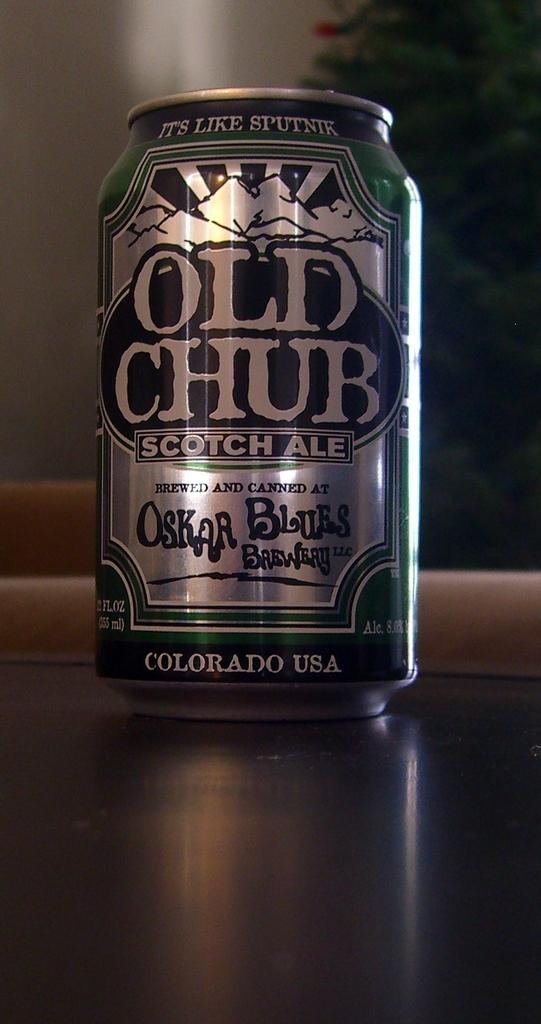<image>
Render a clear and concise summary of the photo. Can can of Old Chub Scotch Ale on a table. 